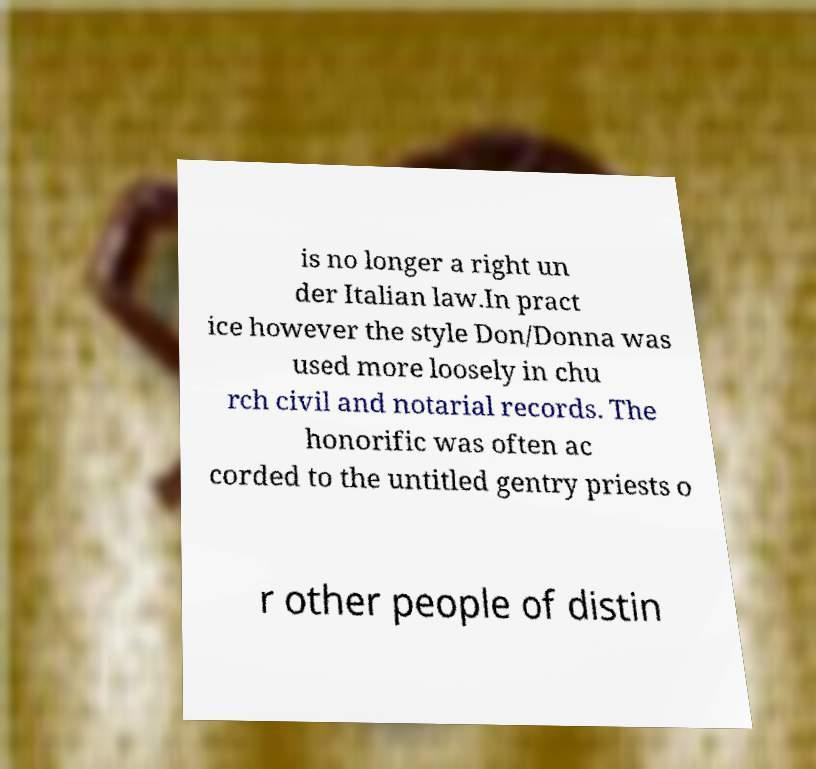Could you extract and type out the text from this image? is no longer a right un der Italian law.In pract ice however the style Don/Donna was used more loosely in chu rch civil and notarial records. The honorific was often ac corded to the untitled gentry priests o r other people of distin 